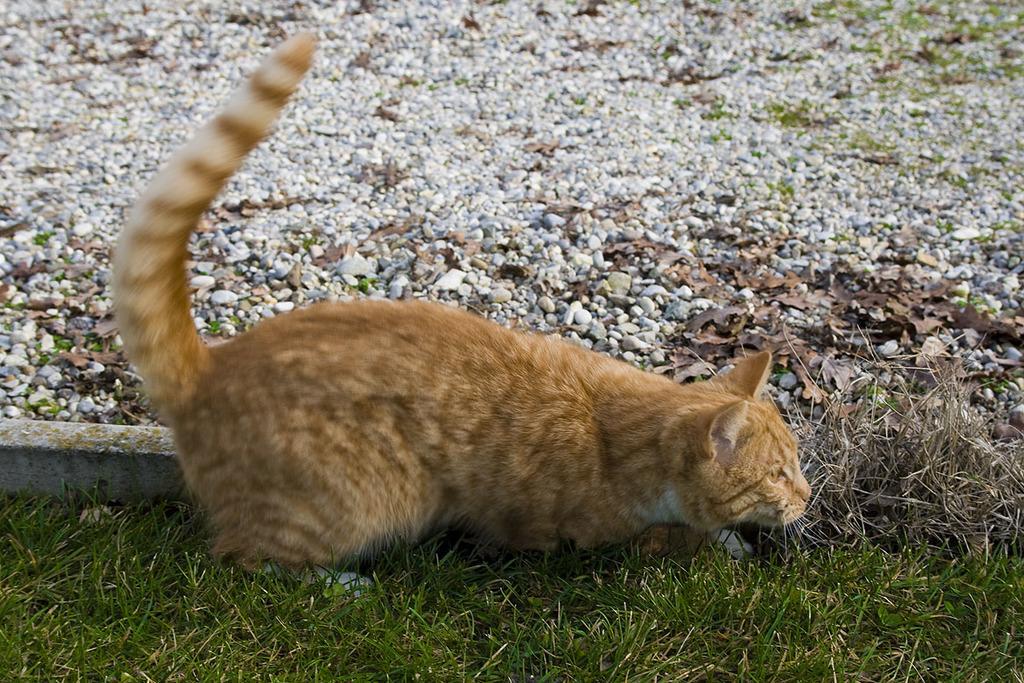Can you describe this image briefly? In this image in the middle, there is a cat. At the bottom there are stones and grass. 